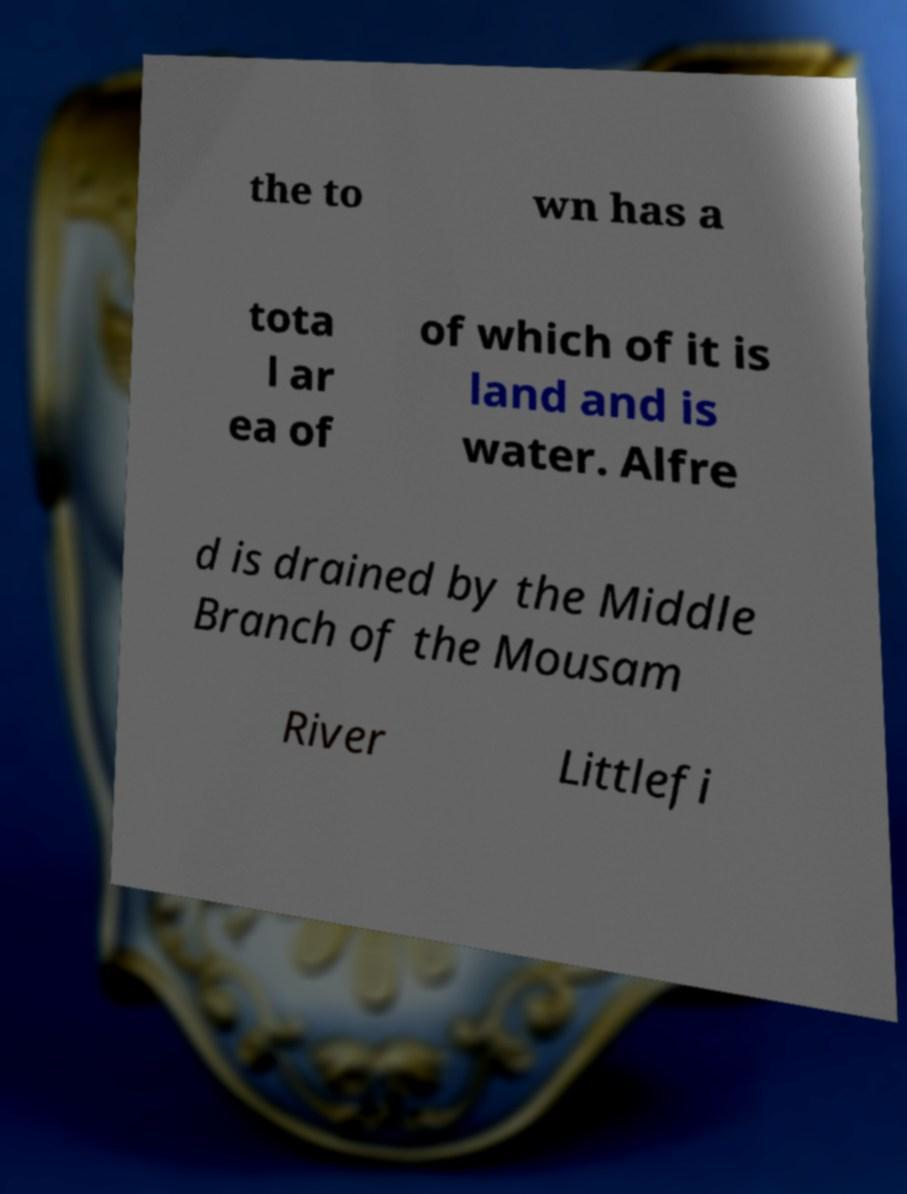I need the written content from this picture converted into text. Can you do that? the to wn has a tota l ar ea of of which of it is land and is water. Alfre d is drained by the Middle Branch of the Mousam River Littlefi 